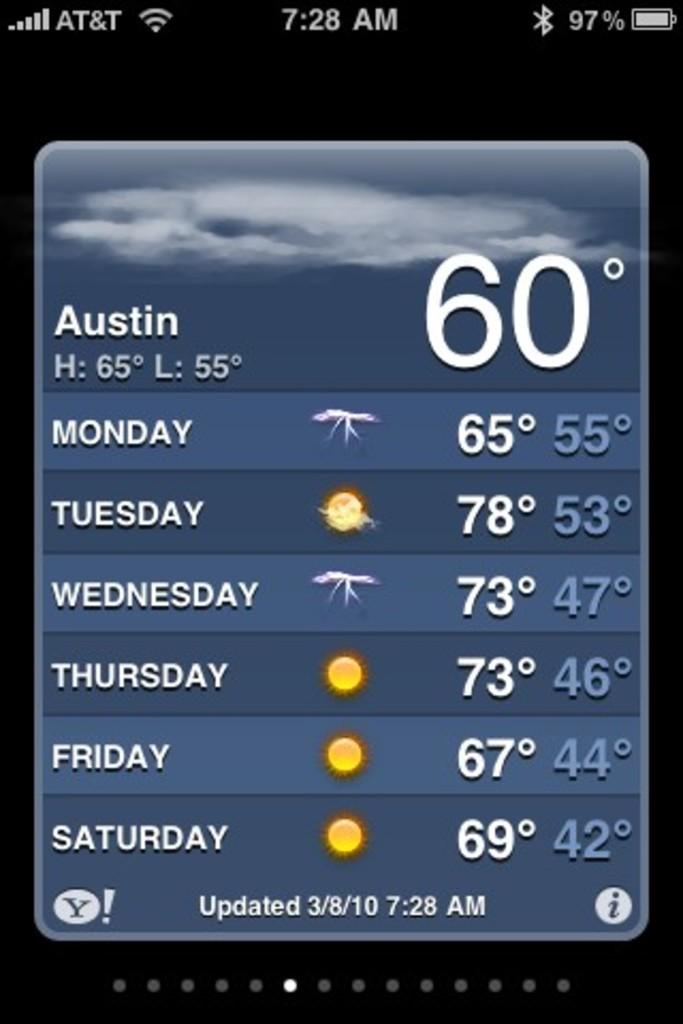What is the temp?
Ensure brevity in your answer.  60. 